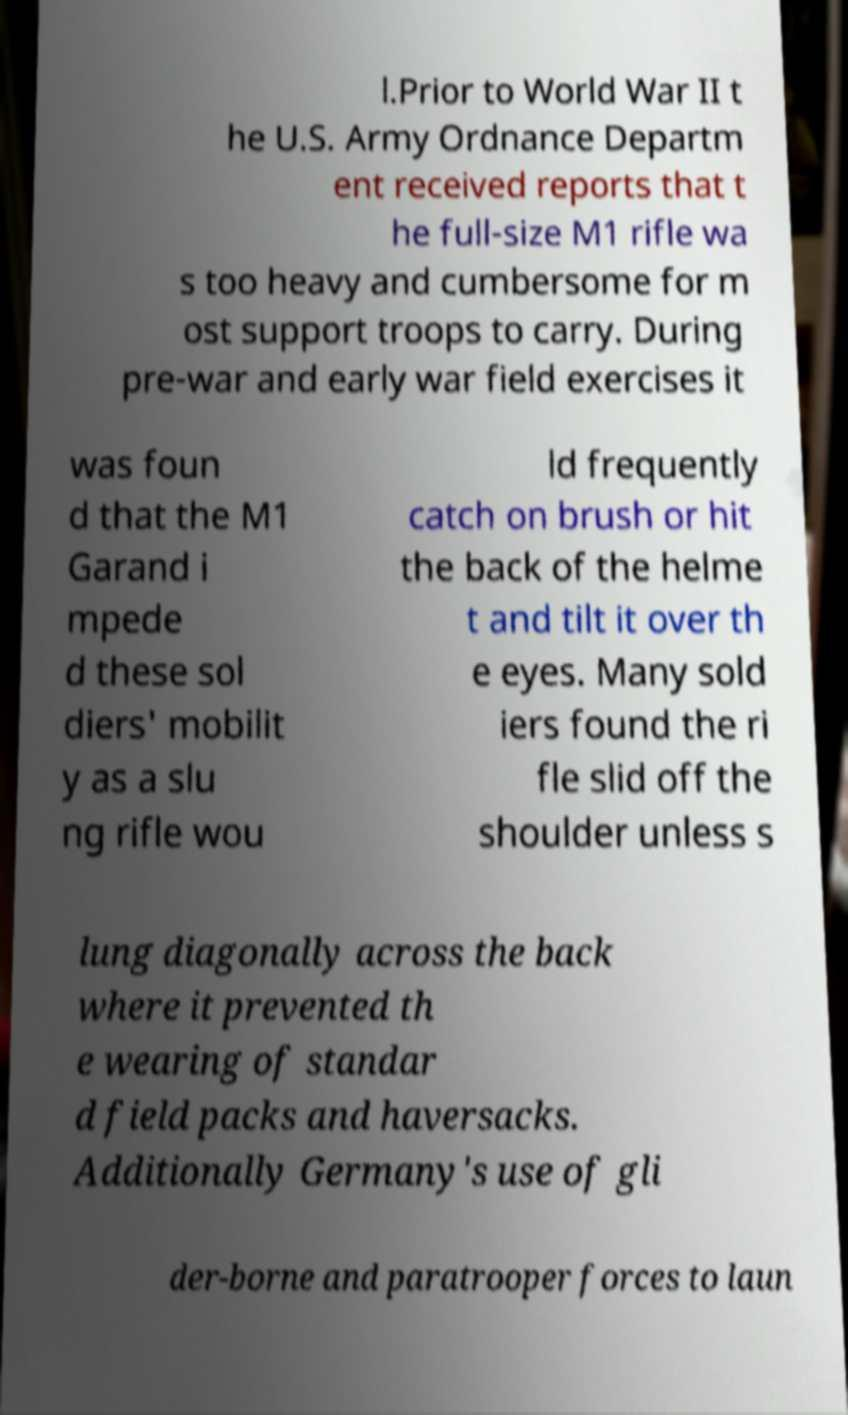Could you extract and type out the text from this image? l.Prior to World War II t he U.S. Army Ordnance Departm ent received reports that t he full-size M1 rifle wa s too heavy and cumbersome for m ost support troops to carry. During pre-war and early war field exercises it was foun d that the M1 Garand i mpede d these sol diers' mobilit y as a slu ng rifle wou ld frequently catch on brush or hit the back of the helme t and tilt it over th e eyes. Many sold iers found the ri fle slid off the shoulder unless s lung diagonally across the back where it prevented th e wearing of standar d field packs and haversacks. Additionally Germany's use of gli der-borne and paratrooper forces to laun 